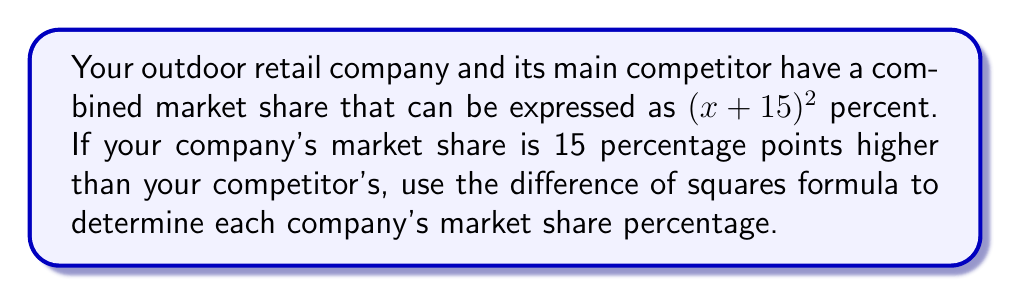Teach me how to tackle this problem. Let's approach this step-by-step:

1) The total market share is $(x + 15)^2$ percent.

2) Your company's market share is 15 percentage points higher than your competitor's. Let's express this mathematically:
   Your company's share: $x + 15$
   Competitor's share: $x$

3) The difference of squares formula is:
   $a^2 - b^2 = (a+b)(a-b)$

4) In our case, we can rearrange the total market share formula:
   $(x + 15)^2 = x^2 + 30x + 225$

5) The difference between your share and your competitor's share is 15:
   $(x + 15) - x = 15$

6) Applying the difference of squares formula:
   $x^2 + 30x + 225 - x^2 = (x + 15 + x)(x + 15 - x)$
   $30x + 225 = (2x + 15)(15)$
   $30x + 225 = 30x + 225$

7) This equality confirms our setup is correct.

8) Now, we can solve for $x$:
   $30x + 225 = 100$ (since the total must be 100%)
   $30x = -125$
   $x = -\frac{125}{30} = -4.1666...$

9) Therefore:
   Competitor's share: $x = -4.1666...$ + 100 = 41.6666...%
   Your company's share: $x + 15 = 56.6666...%$
Answer: Your company's market share: 56.67%
Competitor's market share: 41.67% 